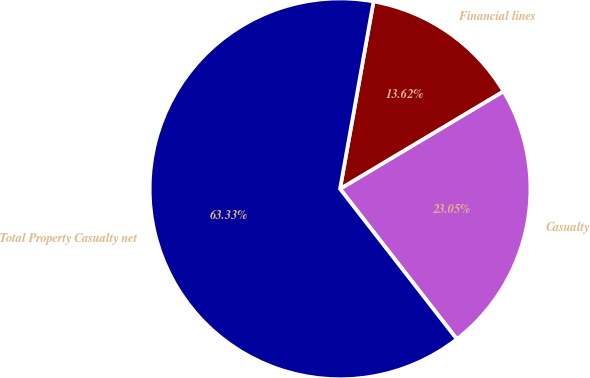Convert chart to OTSL. <chart><loc_0><loc_0><loc_500><loc_500><pie_chart><fcel>Casualty<fcel>Financial lines<fcel>Total Property Casualty net<nl><fcel>23.05%<fcel>13.62%<fcel>63.33%<nl></chart> 